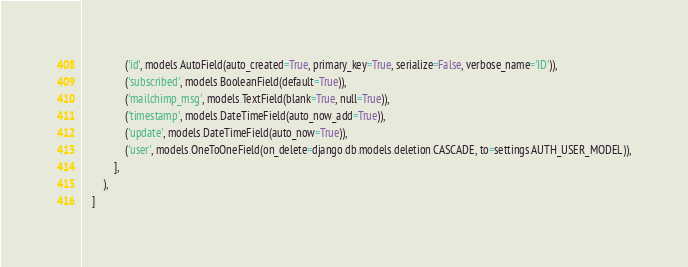<code> <loc_0><loc_0><loc_500><loc_500><_Python_>                ('id', models.AutoField(auto_created=True, primary_key=True, serialize=False, verbose_name='ID')),
                ('subscribed', models.BooleanField(default=True)),
                ('mailchimp_msg', models.TextField(blank=True, null=True)),
                ('timestamp', models.DateTimeField(auto_now_add=True)),
                ('update', models.DateTimeField(auto_now=True)),
                ('user', models.OneToOneField(on_delete=django.db.models.deletion.CASCADE, to=settings.AUTH_USER_MODEL)),
            ],
        ),
    ]
</code> 